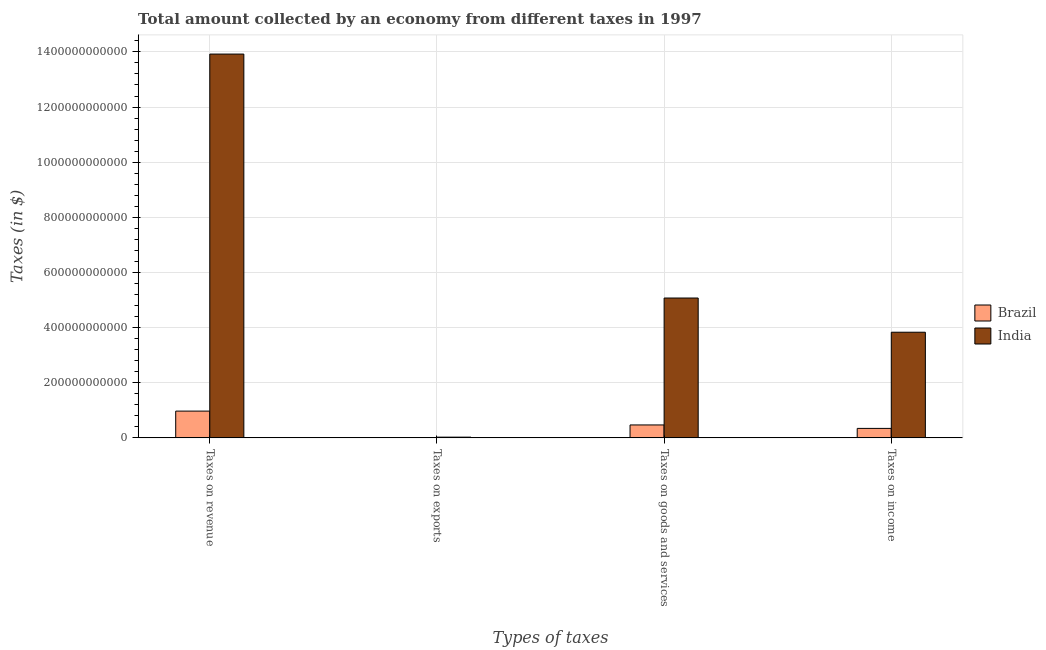How many different coloured bars are there?
Offer a terse response. 2. How many groups of bars are there?
Make the answer very short. 4. How many bars are there on the 1st tick from the left?
Provide a succinct answer. 2. How many bars are there on the 2nd tick from the right?
Provide a succinct answer. 2. What is the label of the 1st group of bars from the left?
Your response must be concise. Taxes on revenue. What is the amount collected as tax on revenue in Brazil?
Your answer should be compact. 9.71e+1. Across all countries, what is the maximum amount collected as tax on goods?
Make the answer very short. 5.07e+11. Across all countries, what is the minimum amount collected as tax on revenue?
Ensure brevity in your answer.  9.71e+1. In which country was the amount collected as tax on revenue minimum?
Give a very brief answer. Brazil. What is the total amount collected as tax on exports in the graph?
Offer a very short reply. 2.64e+09. What is the difference between the amount collected as tax on goods in Brazil and that in India?
Keep it short and to the point. -4.60e+11. What is the difference between the amount collected as tax on goods in Brazil and the amount collected as tax on revenue in India?
Give a very brief answer. -1.35e+12. What is the average amount collected as tax on income per country?
Your answer should be compact. 2.09e+11. What is the difference between the amount collected as tax on revenue and amount collected as tax on income in Brazil?
Provide a short and direct response. 6.27e+1. In how many countries, is the amount collected as tax on income greater than 1280000000000 $?
Give a very brief answer. 0. What is the ratio of the amount collected as tax on exports in India to that in Brazil?
Offer a very short reply. 910.34. Is the difference between the amount collected as tax on income in Brazil and India greater than the difference between the amount collected as tax on revenue in Brazil and India?
Make the answer very short. Yes. What is the difference between the highest and the second highest amount collected as tax on goods?
Offer a terse response. 4.60e+11. What is the difference between the highest and the lowest amount collected as tax on goods?
Your response must be concise. 4.60e+11. In how many countries, is the amount collected as tax on income greater than the average amount collected as tax on income taken over all countries?
Your answer should be very brief. 1. Is the sum of the amount collected as tax on goods in India and Brazil greater than the maximum amount collected as tax on income across all countries?
Offer a terse response. Yes. Is it the case that in every country, the sum of the amount collected as tax on goods and amount collected as tax on exports is greater than the sum of amount collected as tax on income and amount collected as tax on revenue?
Keep it short and to the point. No. What does the 1st bar from the left in Taxes on revenue represents?
Offer a terse response. Brazil. Is it the case that in every country, the sum of the amount collected as tax on revenue and amount collected as tax on exports is greater than the amount collected as tax on goods?
Give a very brief answer. Yes. How many bars are there?
Your answer should be very brief. 8. How many countries are there in the graph?
Your answer should be very brief. 2. What is the difference between two consecutive major ticks on the Y-axis?
Provide a succinct answer. 2.00e+11. How many legend labels are there?
Offer a very short reply. 2. How are the legend labels stacked?
Your response must be concise. Vertical. What is the title of the graph?
Provide a short and direct response. Total amount collected by an economy from different taxes in 1997. Does "Mexico" appear as one of the legend labels in the graph?
Your response must be concise. No. What is the label or title of the X-axis?
Ensure brevity in your answer.  Types of taxes. What is the label or title of the Y-axis?
Offer a terse response. Taxes (in $). What is the Taxes (in $) of Brazil in Taxes on revenue?
Make the answer very short. 9.71e+1. What is the Taxes (in $) of India in Taxes on revenue?
Offer a very short reply. 1.39e+12. What is the Taxes (in $) of Brazil in Taxes on exports?
Your answer should be compact. 2.90e+06. What is the Taxes (in $) in India in Taxes on exports?
Provide a short and direct response. 2.64e+09. What is the Taxes (in $) in Brazil in Taxes on goods and services?
Make the answer very short. 4.69e+1. What is the Taxes (in $) in India in Taxes on goods and services?
Give a very brief answer. 5.07e+11. What is the Taxes (in $) in Brazil in Taxes on income?
Offer a terse response. 3.44e+1. What is the Taxes (in $) in India in Taxes on income?
Make the answer very short. 3.83e+11. Across all Types of taxes, what is the maximum Taxes (in $) in Brazil?
Your answer should be very brief. 9.71e+1. Across all Types of taxes, what is the maximum Taxes (in $) in India?
Your answer should be very brief. 1.39e+12. Across all Types of taxes, what is the minimum Taxes (in $) of Brazil?
Provide a succinct answer. 2.90e+06. Across all Types of taxes, what is the minimum Taxes (in $) of India?
Keep it short and to the point. 2.64e+09. What is the total Taxes (in $) in Brazil in the graph?
Your answer should be very brief. 1.78e+11. What is the total Taxes (in $) in India in the graph?
Your answer should be very brief. 2.29e+12. What is the difference between the Taxes (in $) in Brazil in Taxes on revenue and that in Taxes on exports?
Offer a terse response. 9.71e+1. What is the difference between the Taxes (in $) of India in Taxes on revenue and that in Taxes on exports?
Provide a succinct answer. 1.39e+12. What is the difference between the Taxes (in $) in Brazil in Taxes on revenue and that in Taxes on goods and services?
Offer a very short reply. 5.02e+1. What is the difference between the Taxes (in $) in India in Taxes on revenue and that in Taxes on goods and services?
Ensure brevity in your answer.  8.85e+11. What is the difference between the Taxes (in $) of Brazil in Taxes on revenue and that in Taxes on income?
Make the answer very short. 6.27e+1. What is the difference between the Taxes (in $) of India in Taxes on revenue and that in Taxes on income?
Ensure brevity in your answer.  1.01e+12. What is the difference between the Taxes (in $) of Brazil in Taxes on exports and that in Taxes on goods and services?
Your answer should be very brief. -4.69e+1. What is the difference between the Taxes (in $) in India in Taxes on exports and that in Taxes on goods and services?
Provide a succinct answer. -5.05e+11. What is the difference between the Taxes (in $) in Brazil in Taxes on exports and that in Taxes on income?
Offer a terse response. -3.44e+1. What is the difference between the Taxes (in $) of India in Taxes on exports and that in Taxes on income?
Give a very brief answer. -3.81e+11. What is the difference between the Taxes (in $) of Brazil in Taxes on goods and services and that in Taxes on income?
Offer a terse response. 1.25e+1. What is the difference between the Taxes (in $) in India in Taxes on goods and services and that in Taxes on income?
Make the answer very short. 1.24e+11. What is the difference between the Taxes (in $) in Brazil in Taxes on revenue and the Taxes (in $) in India in Taxes on exports?
Provide a short and direct response. 9.44e+1. What is the difference between the Taxes (in $) of Brazil in Taxes on revenue and the Taxes (in $) of India in Taxes on goods and services?
Make the answer very short. -4.10e+11. What is the difference between the Taxes (in $) in Brazil in Taxes on revenue and the Taxes (in $) in India in Taxes on income?
Your response must be concise. -2.86e+11. What is the difference between the Taxes (in $) of Brazil in Taxes on exports and the Taxes (in $) of India in Taxes on goods and services?
Your response must be concise. -5.07e+11. What is the difference between the Taxes (in $) in Brazil in Taxes on exports and the Taxes (in $) in India in Taxes on income?
Offer a very short reply. -3.83e+11. What is the difference between the Taxes (in $) of Brazil in Taxes on goods and services and the Taxes (in $) of India in Taxes on income?
Your answer should be compact. -3.36e+11. What is the average Taxes (in $) in Brazil per Types of taxes?
Make the answer very short. 4.46e+1. What is the average Taxes (in $) in India per Types of taxes?
Your response must be concise. 5.71e+11. What is the difference between the Taxes (in $) of Brazil and Taxes (in $) of India in Taxes on revenue?
Offer a very short reply. -1.30e+12. What is the difference between the Taxes (in $) of Brazil and Taxes (in $) of India in Taxes on exports?
Your answer should be compact. -2.64e+09. What is the difference between the Taxes (in $) in Brazil and Taxes (in $) in India in Taxes on goods and services?
Your answer should be very brief. -4.60e+11. What is the difference between the Taxes (in $) of Brazil and Taxes (in $) of India in Taxes on income?
Provide a short and direct response. -3.49e+11. What is the ratio of the Taxes (in $) of Brazil in Taxes on revenue to that in Taxes on exports?
Offer a terse response. 3.35e+04. What is the ratio of the Taxes (in $) in India in Taxes on revenue to that in Taxes on exports?
Your response must be concise. 527.34. What is the ratio of the Taxes (in $) in Brazil in Taxes on revenue to that in Taxes on goods and services?
Your answer should be compact. 2.07. What is the ratio of the Taxes (in $) of India in Taxes on revenue to that in Taxes on goods and services?
Give a very brief answer. 2.74. What is the ratio of the Taxes (in $) of Brazil in Taxes on revenue to that in Taxes on income?
Give a very brief answer. 2.83. What is the ratio of the Taxes (in $) of India in Taxes on revenue to that in Taxes on income?
Provide a succinct answer. 3.63. What is the ratio of the Taxes (in $) of India in Taxes on exports to that in Taxes on goods and services?
Your answer should be very brief. 0.01. What is the ratio of the Taxes (in $) of India in Taxes on exports to that in Taxes on income?
Keep it short and to the point. 0.01. What is the ratio of the Taxes (in $) in Brazil in Taxes on goods and services to that in Taxes on income?
Provide a succinct answer. 1.36. What is the ratio of the Taxes (in $) in India in Taxes on goods and services to that in Taxes on income?
Your response must be concise. 1.32. What is the difference between the highest and the second highest Taxes (in $) of Brazil?
Your answer should be very brief. 5.02e+1. What is the difference between the highest and the second highest Taxes (in $) of India?
Provide a short and direct response. 8.85e+11. What is the difference between the highest and the lowest Taxes (in $) in Brazil?
Provide a short and direct response. 9.71e+1. What is the difference between the highest and the lowest Taxes (in $) in India?
Provide a short and direct response. 1.39e+12. 